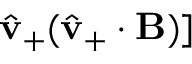<formula> <loc_0><loc_0><loc_500><loc_500>\hat { v } _ { + } ( \hat { v } _ { + } \cdot B ) ]</formula> 